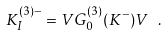<formula> <loc_0><loc_0><loc_500><loc_500>K _ { I } ^ { ( 3 ) - } = V G _ { 0 } ^ { ( 3 ) } ( K ^ { - } ) V \ .</formula> 